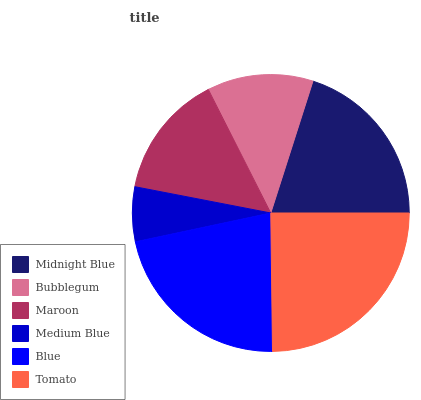Is Medium Blue the minimum?
Answer yes or no. Yes. Is Tomato the maximum?
Answer yes or no. Yes. Is Bubblegum the minimum?
Answer yes or no. No. Is Bubblegum the maximum?
Answer yes or no. No. Is Midnight Blue greater than Bubblegum?
Answer yes or no. Yes. Is Bubblegum less than Midnight Blue?
Answer yes or no. Yes. Is Bubblegum greater than Midnight Blue?
Answer yes or no. No. Is Midnight Blue less than Bubblegum?
Answer yes or no. No. Is Midnight Blue the high median?
Answer yes or no. Yes. Is Maroon the low median?
Answer yes or no. Yes. Is Medium Blue the high median?
Answer yes or no. No. Is Bubblegum the low median?
Answer yes or no. No. 